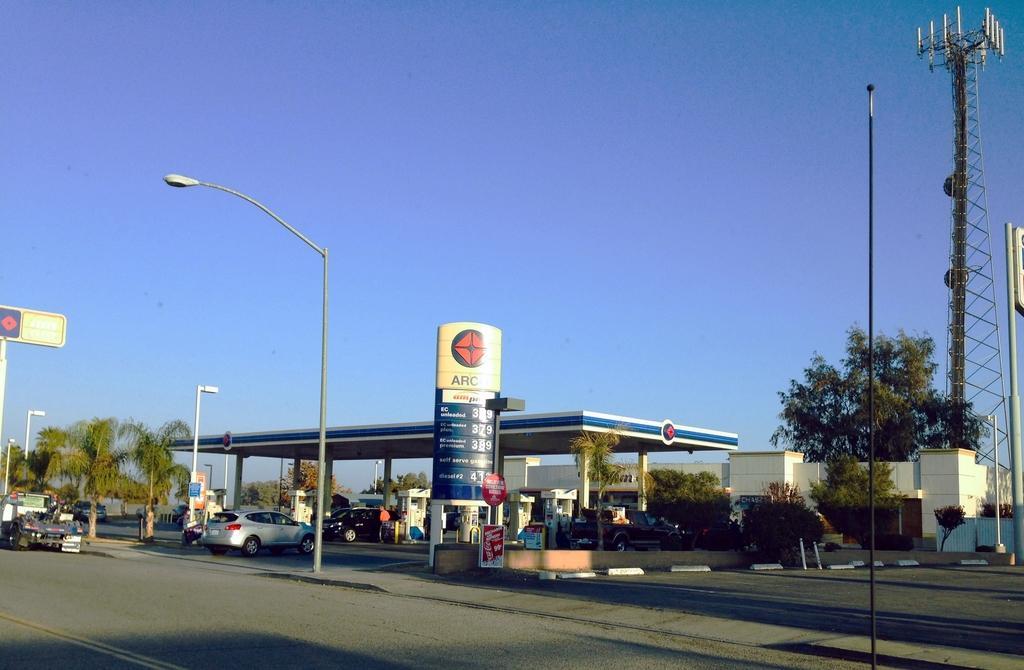In one or two sentences, can you explain what this image depicts? Here in this picture, in the middle we can see a petrol pump present and in that we can see number of cars present and in the middle we can see a hoarding present and on the road we can see light posts present and on the right side we can see a tower present and on the ground we can see plants and trees present and we can also see a store present on the right side and we can see some sign b oards present and we can see the sky is clear. 